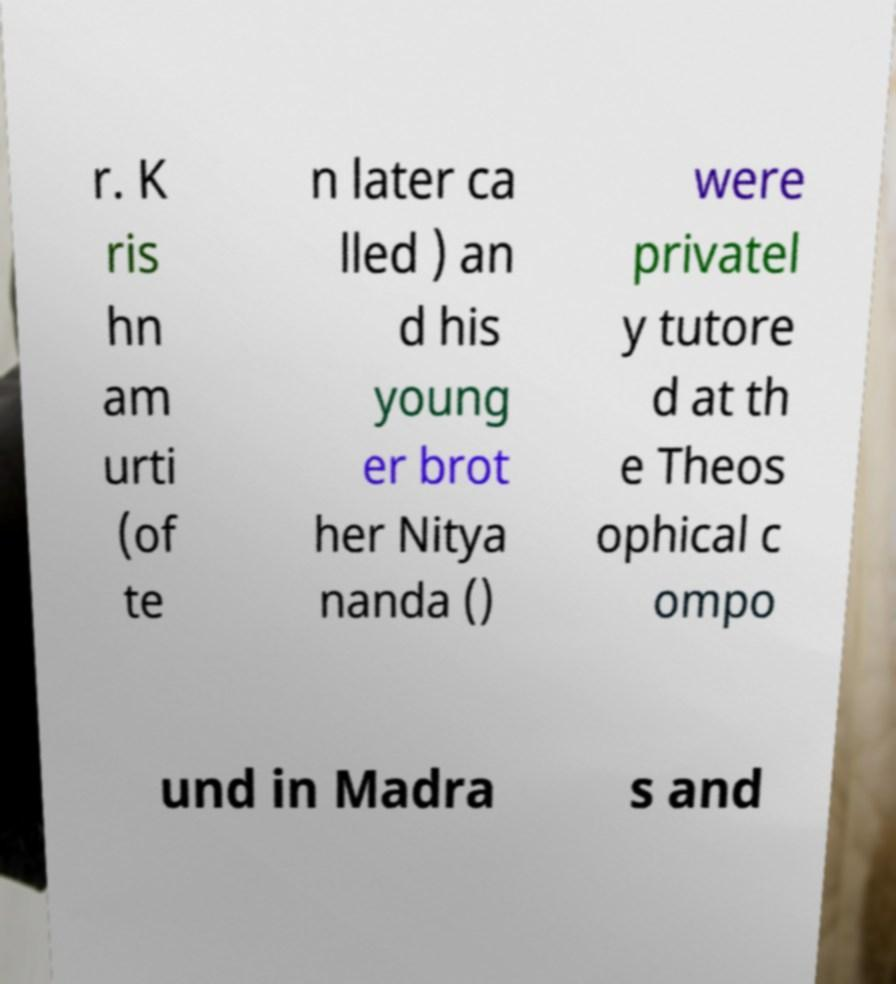Can you accurately transcribe the text from the provided image for me? r. K ris hn am urti (of te n later ca lled ) an d his young er brot her Nitya nanda () were privatel y tutore d at th e Theos ophical c ompo und in Madra s and 